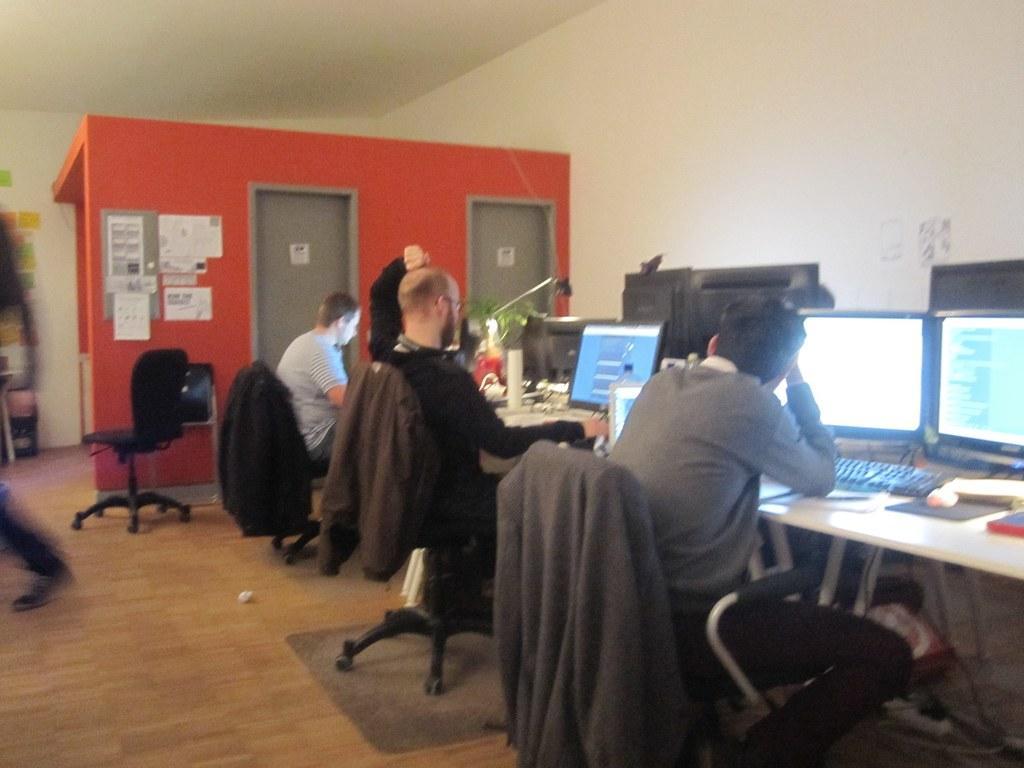Describe this image in one or two sentences. This is the picture of a room with three people sitting on chairs in front of the desk where we have systems and some things. 